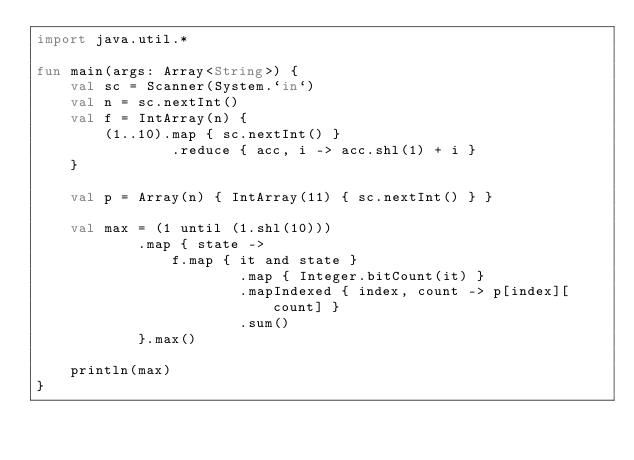<code> <loc_0><loc_0><loc_500><loc_500><_Kotlin_>import java.util.*

fun main(args: Array<String>) {
    val sc = Scanner(System.`in`)
    val n = sc.nextInt()
    val f = IntArray(n) {
        (1..10).map { sc.nextInt() }
                .reduce { acc, i -> acc.shl(1) + i }
    }

    val p = Array(n) { IntArray(11) { sc.nextInt() } }
    
    val max = (1 until (1.shl(10)))
            .map { state ->
                f.map { it and state }
                        .map { Integer.bitCount(it) }
                        .mapIndexed { index, count -> p[index][count] }
                        .sum()
            }.max()

    println(max)
}</code> 